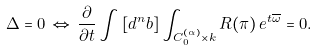Convert formula to latex. <formula><loc_0><loc_0><loc_500><loc_500>\Delta = 0 \, \Leftrightarrow \, \frac { \partial } { \partial t } \int \left [ d ^ { n } b \right ] \int _ { C _ { 0 } ^ { ( \alpha ) } \times k } R ( \pi ) \, e ^ { t \overline { \omega } } = 0 .</formula> 